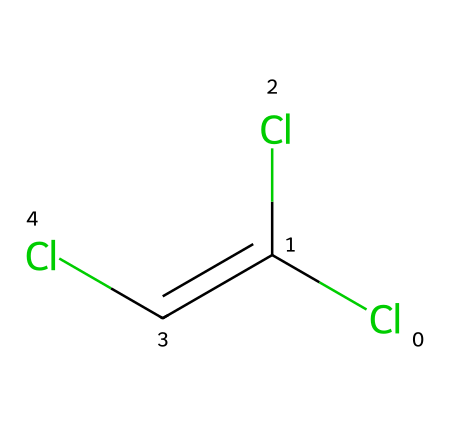How many chlorine atoms are in trichloroethylene? The chemical structure shows three chlorine (Cl) atoms attached to a carbon chain. You can count the number of Cl atoms graphically represented in the SMILES.
Answer: three What is the primary functional group in trichloroethylene? The structure indicates that it is a vinyl compound with a double bond between two carbon atoms. The presence of the double bond characterizes it as an alkene.
Answer: alkene What is the total number of carbon atoms in trichloroethylene? The SMILES representation has a total of two carbon (C) atoms connected via a double bond and indicated by the C(C) structure.
Answer: two Is trichloroethylene polar or nonpolar? The presence of multiple chlorine atoms, which are more electronegative than carbon, creates a dipole moment in the molecule, indicating it is polar.
Answer: polar What type of solvent is trichloroethylene classified as? Trichloroethylene is used primarily as a degreasing agent, and in chemical terms, it falls under the category of halogenated solvents due to its chlorine content.
Answer: halogenated solvent How does the presence of chlorine atoms affect the properties of trichloroethylene? Chlorine atoms increase the solvent's ability to dissolve oils and grease, making it effective for industrial applications. They also influence its volatility and toxicity.
Answer: increases dissolving power What is the significance of the double bond in trichloroethylene's structure? The double bond affects the reactivity of the molecule, allowing it to participate in addition reactions, which are essential for its use in various chemical processes, such as degreasing.
Answer: increases reactivity 